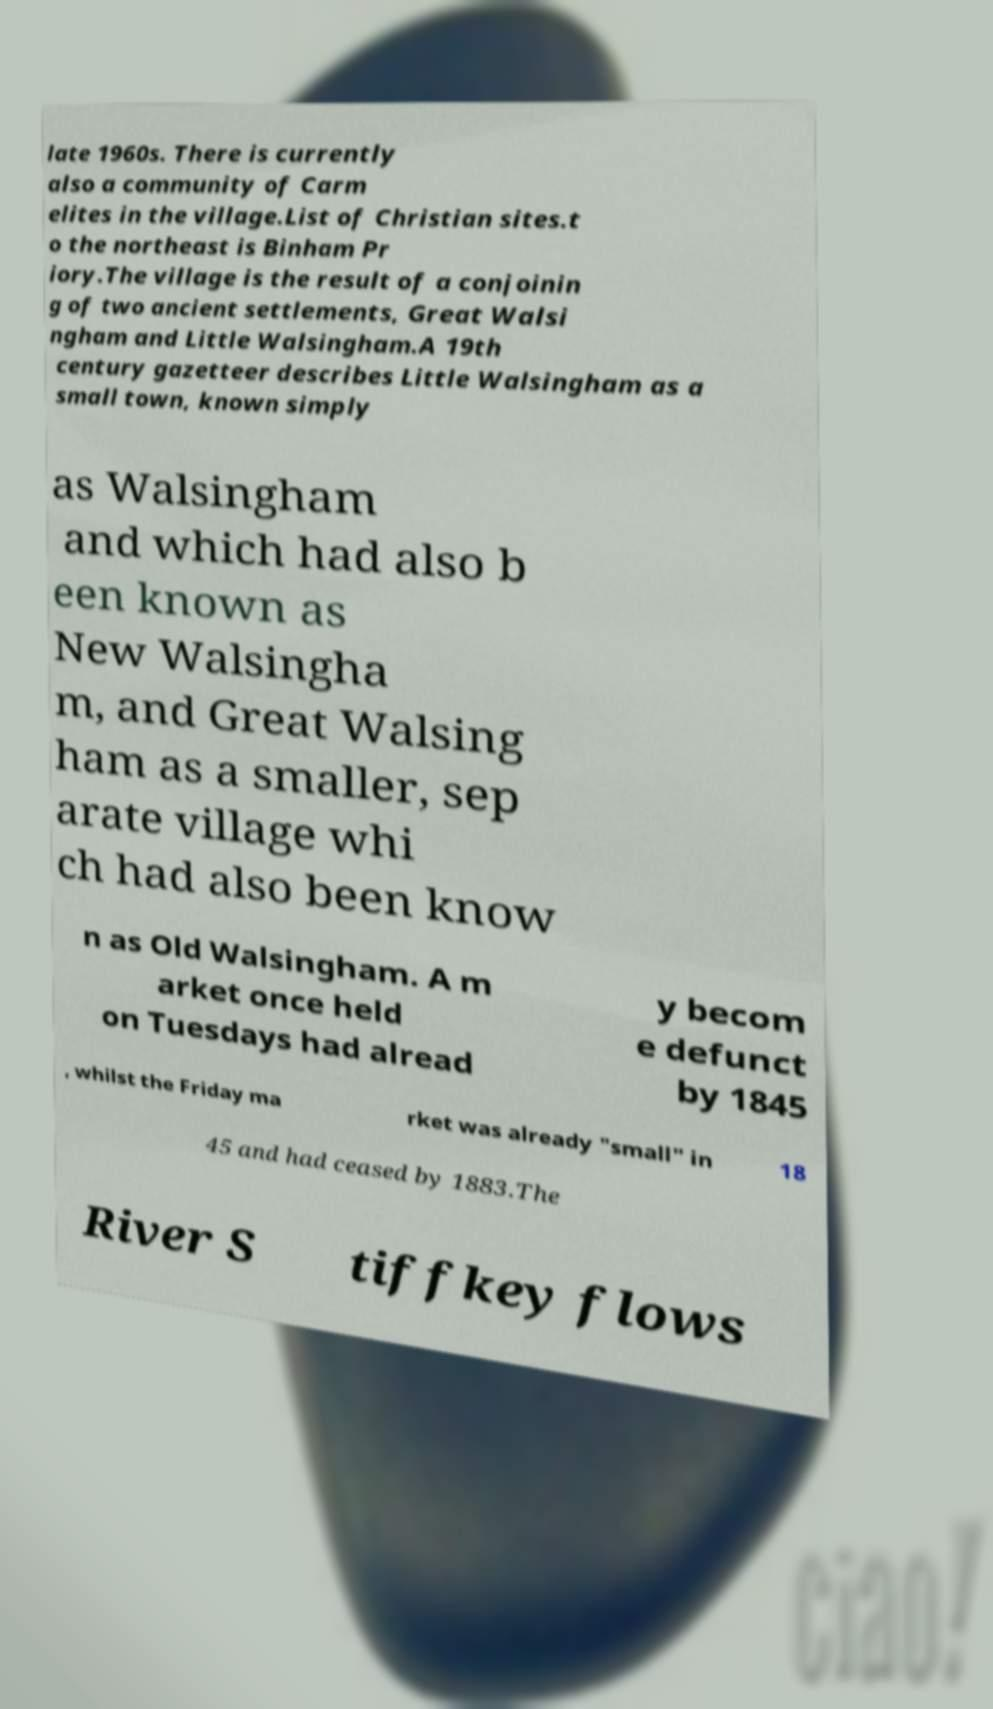Can you read and provide the text displayed in the image?This photo seems to have some interesting text. Can you extract and type it out for me? late 1960s. There is currently also a community of Carm elites in the village.List of Christian sites.t o the northeast is Binham Pr iory.The village is the result of a conjoinin g of two ancient settlements, Great Walsi ngham and Little Walsingham.A 19th century gazetteer describes Little Walsingham as a small town, known simply as Walsingham and which had also b een known as New Walsingha m, and Great Walsing ham as a smaller, sep arate village whi ch had also been know n as Old Walsingham. A m arket once held on Tuesdays had alread y becom e defunct by 1845 , whilst the Friday ma rket was already "small" in 18 45 and had ceased by 1883.The River S tiffkey flows 